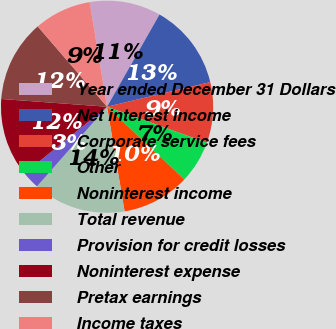Convert chart to OTSL. <chart><loc_0><loc_0><loc_500><loc_500><pie_chart><fcel>Year ended December 31 Dollars<fcel>Net interest income<fcel>Corporate service fees<fcel>Other<fcel>Noninterest income<fcel>Total revenue<fcel>Provision for credit losses<fcel>Noninterest expense<fcel>Pretax earnings<fcel>Income taxes<nl><fcel>10.87%<fcel>13.04%<fcel>9.24%<fcel>6.52%<fcel>10.33%<fcel>14.13%<fcel>2.72%<fcel>11.96%<fcel>12.5%<fcel>8.7%<nl></chart> 